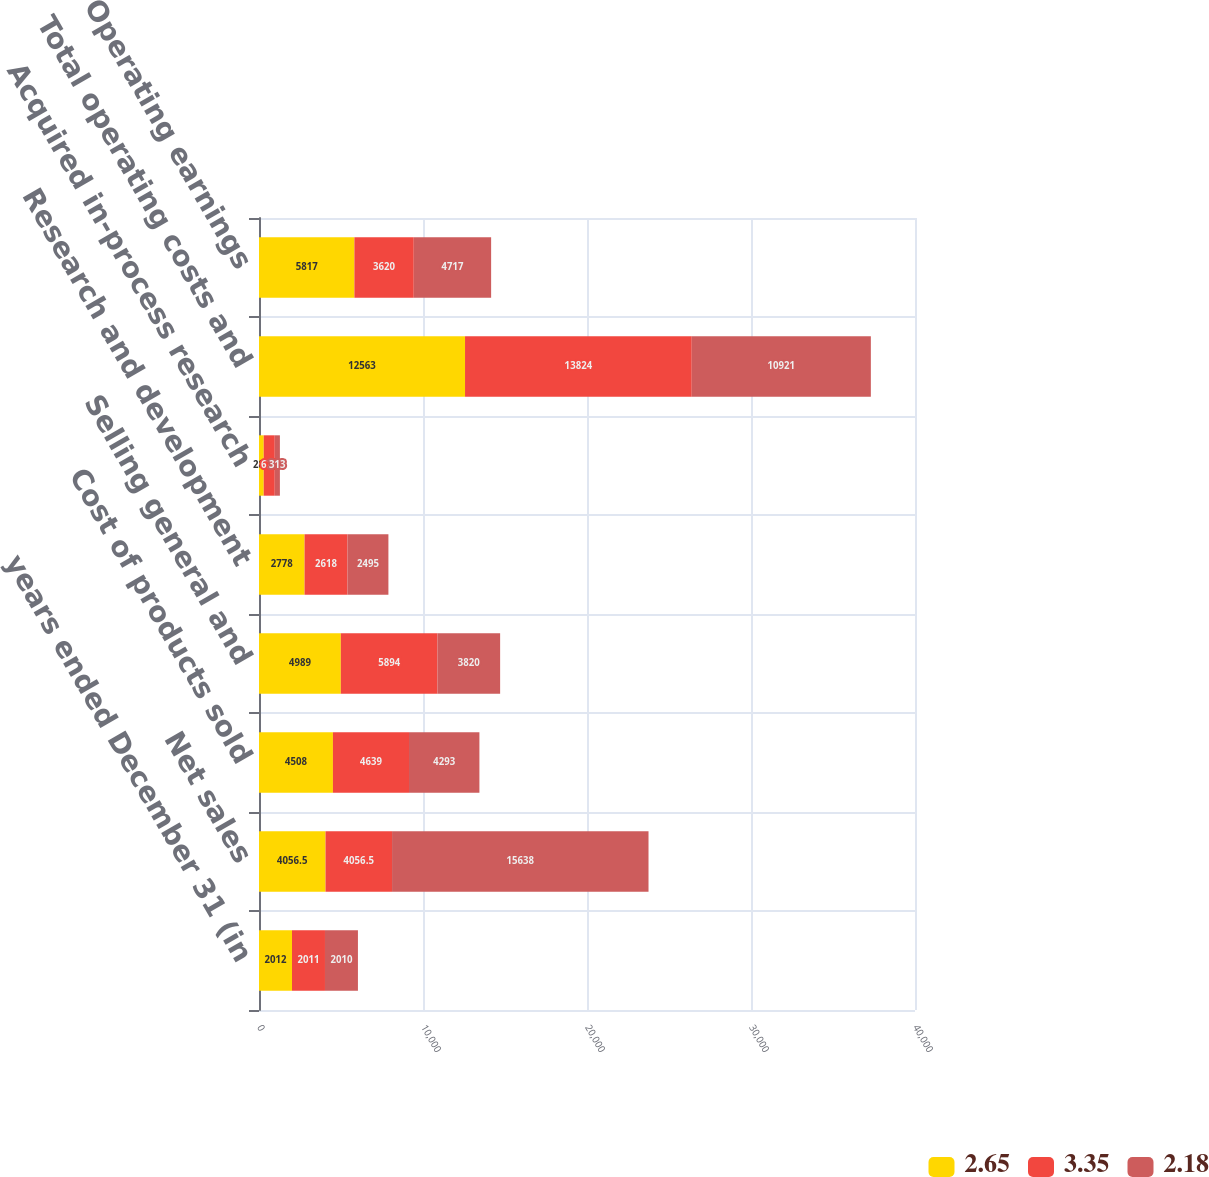Convert chart to OTSL. <chart><loc_0><loc_0><loc_500><loc_500><stacked_bar_chart><ecel><fcel>years ended December 31 (in<fcel>Net sales<fcel>Cost of products sold<fcel>Selling general and<fcel>Research and development<fcel>Acquired in-process research<fcel>Total operating costs and<fcel>Operating earnings<nl><fcel>2.65<fcel>2012<fcel>4056.5<fcel>4508<fcel>4989<fcel>2778<fcel>288<fcel>12563<fcel>5817<nl><fcel>3.35<fcel>2011<fcel>4056.5<fcel>4639<fcel>5894<fcel>2618<fcel>673<fcel>13824<fcel>3620<nl><fcel>2.18<fcel>2010<fcel>15638<fcel>4293<fcel>3820<fcel>2495<fcel>313<fcel>10921<fcel>4717<nl></chart> 